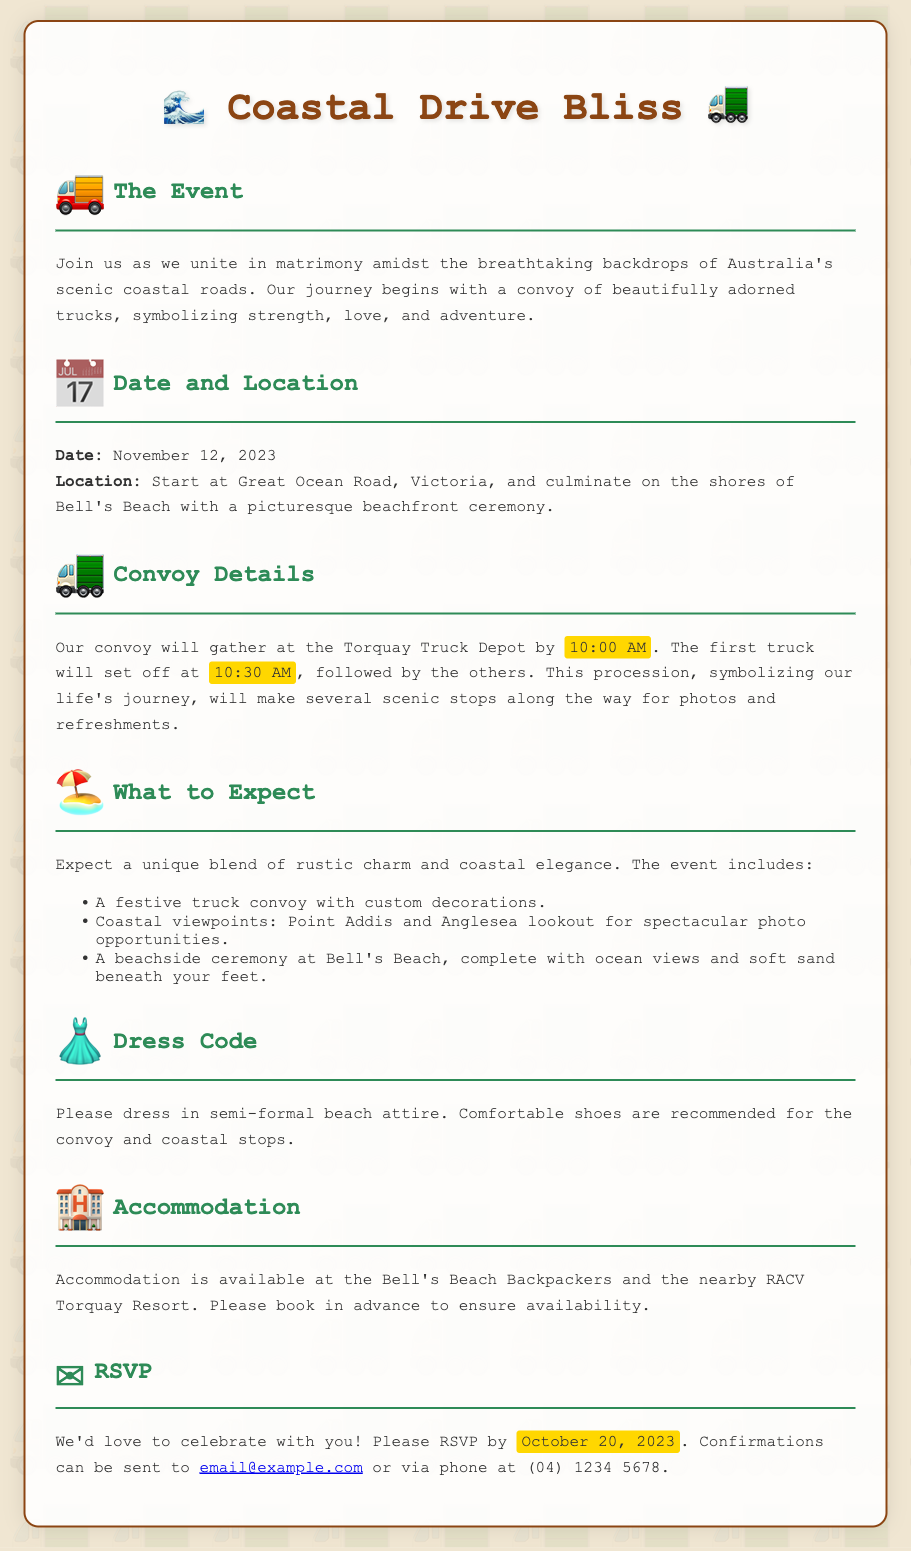What is the date of the wedding? The wedding date is clearly stated in the document under the Date and Location section.
Answer: November 12, 2023 Where does the ceremony take place? The location of the ceremony is mentioned in the same section, specifying the end point of the event.
Answer: Bell's Beach What time does the convoy start gathering? The document specifies this detail under the Convoy Details section.
Answer: 10:00 AM How many trucks are expected in the convoy? Though not explicitly stated, the truck convoy is referred to as a festive event, implying multiple trucks, but no specific number is given.
Answer: Not specified What is the recommended dress code? This is outlined in the Dress Code section of the invitation.
Answer: Semi-formal beach attire What are the accommodation options mentioned? The Accommodation section includes details about where guests can stay.
Answer: Bell's Beach Backpackers and RACV Torquay Resort By what date should RSVPs be sent? This is mentioned in the RSVP section of the document.
Answer: October 20, 2023 What type of ceremony is being held? The nature of the ceremony is highlighted in the What to Expect section.
Answer: Beachside ceremony 